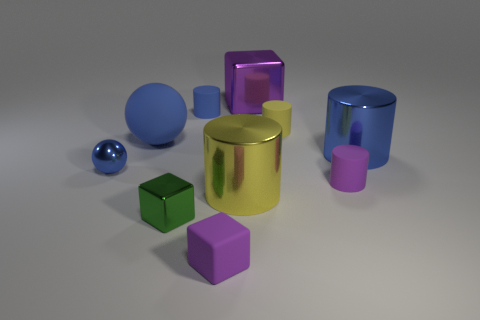There is a purple cube in front of the metal cube that is behind the green block; what is it made of?
Make the answer very short. Rubber. There is a green thing; is its size the same as the blue cylinder on the left side of the tiny purple matte cube?
Your answer should be very brief. Yes. Are there any rubber objects of the same color as the big sphere?
Your answer should be very brief. Yes. How many large things are blue rubber things or purple objects?
Your answer should be compact. 2. What number of yellow metal objects are there?
Your answer should be compact. 1. What is the material of the large object that is to the left of the big yellow object?
Make the answer very short. Rubber. There is a big yellow metal cylinder; are there any purple cylinders in front of it?
Offer a very short reply. No. Is the size of the blue matte cylinder the same as the purple metal cube?
Your answer should be compact. No. What number of blue cubes are made of the same material as the large purple thing?
Make the answer very short. 0. What is the size of the blue thing that is to the right of the rubber object that is in front of the yellow metal thing?
Offer a very short reply. Large. 